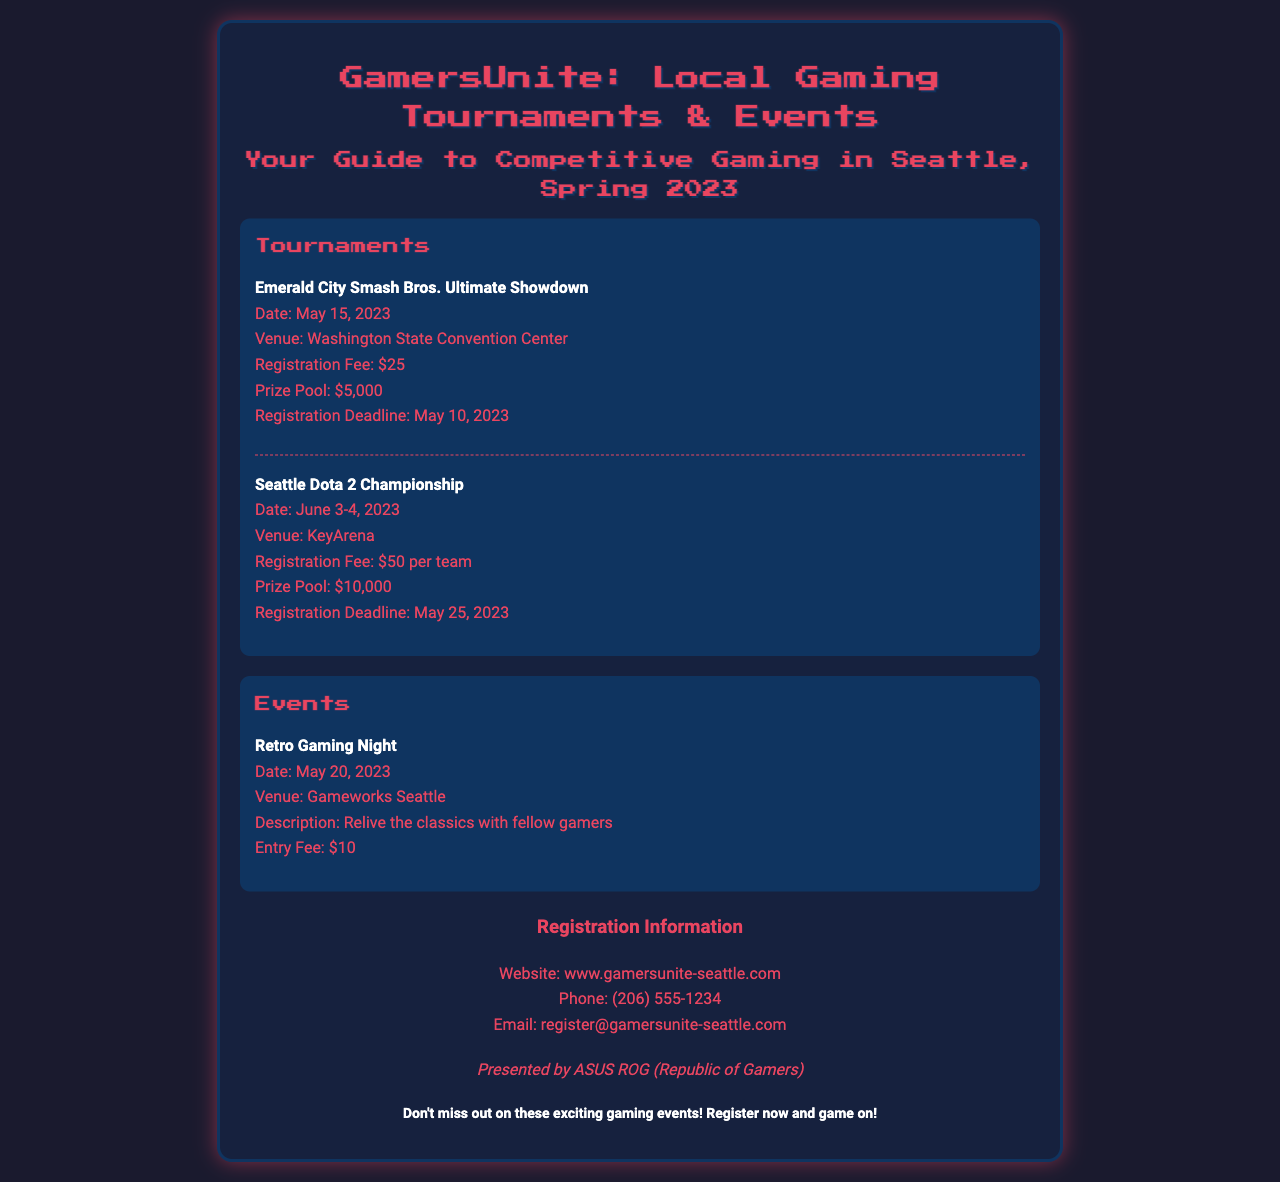What is the name of the first tournament? The first tournament listed in the document is "Emerald City Smash Bros. Ultimate Showdown."
Answer: Emerald City Smash Bros. Ultimate Showdown When is the Seattle Dota 2 Championship scheduled? The Seattle Dota 2 Championship is set for June 3-4, 2023.
Answer: June 3-4, 2023 What is the prize pool for the Emerald City Smash Bros. Ultimate Showdown? The prize pool for that tournament is $5,000.
Answer: $5,000 How much is the registration fee for the Retro Gaming Night? The entry fee for Retro Gaming Night is $10.
Answer: $10 What is the registration deadline for the Seattle Dota 2 Championship? The registration deadline for this championship is May 25, 2023.
Answer: May 25, 2023 Which venue will host the Emerald City Smash Bros. Ultimate Showdown? The event will take place at the Washington State Convention Center.
Answer: Washington State Convention Center How can participants register for the events? Participants can register through the website or contact the provided phone number or email.
Answer: Website: www.gamersunite-seattle.com What is the total prize pool for all listed tournaments? The total prize pool is the sum of both tournaments' prize pools: $5,000 + $10,000 = $15,000.
Answer: $15,000 Which company is sponsoring the events? The events are presented by ASUS ROG (Republic of Gamers).
Answer: ASUS ROG (Republic of Gamers) 